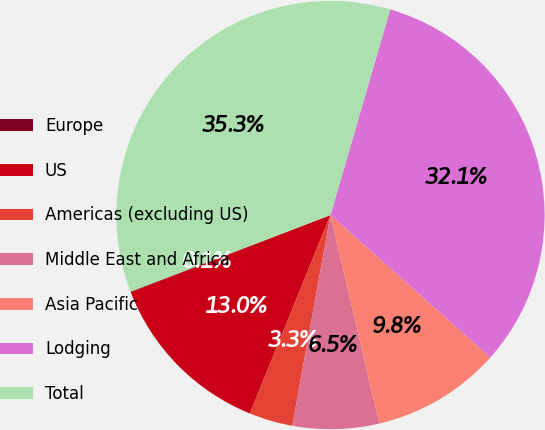Convert chart. <chart><loc_0><loc_0><loc_500><loc_500><pie_chart><fcel>Europe<fcel>US<fcel>Americas (excluding US)<fcel>Middle East and Africa<fcel>Asia Pacific<fcel>Lodging<fcel>Total<nl><fcel>0.05%<fcel>12.99%<fcel>3.29%<fcel>6.52%<fcel>9.75%<fcel>32.08%<fcel>35.32%<nl></chart> 